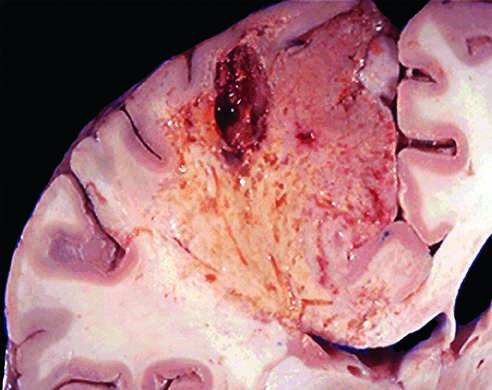what does an infarct in the brain show of the tissue?
Answer the question using a single word or phrase. Dissolution of the tissue 